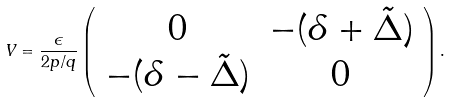<formula> <loc_0><loc_0><loc_500><loc_500>V = \frac { \epsilon } { 2 p / q } \left ( \begin{array} { c c } 0 & - ( \delta + \tilde { \Delta } ) \\ - ( \delta - \tilde { \Delta } ) & 0 \end{array} \right ) .</formula> 